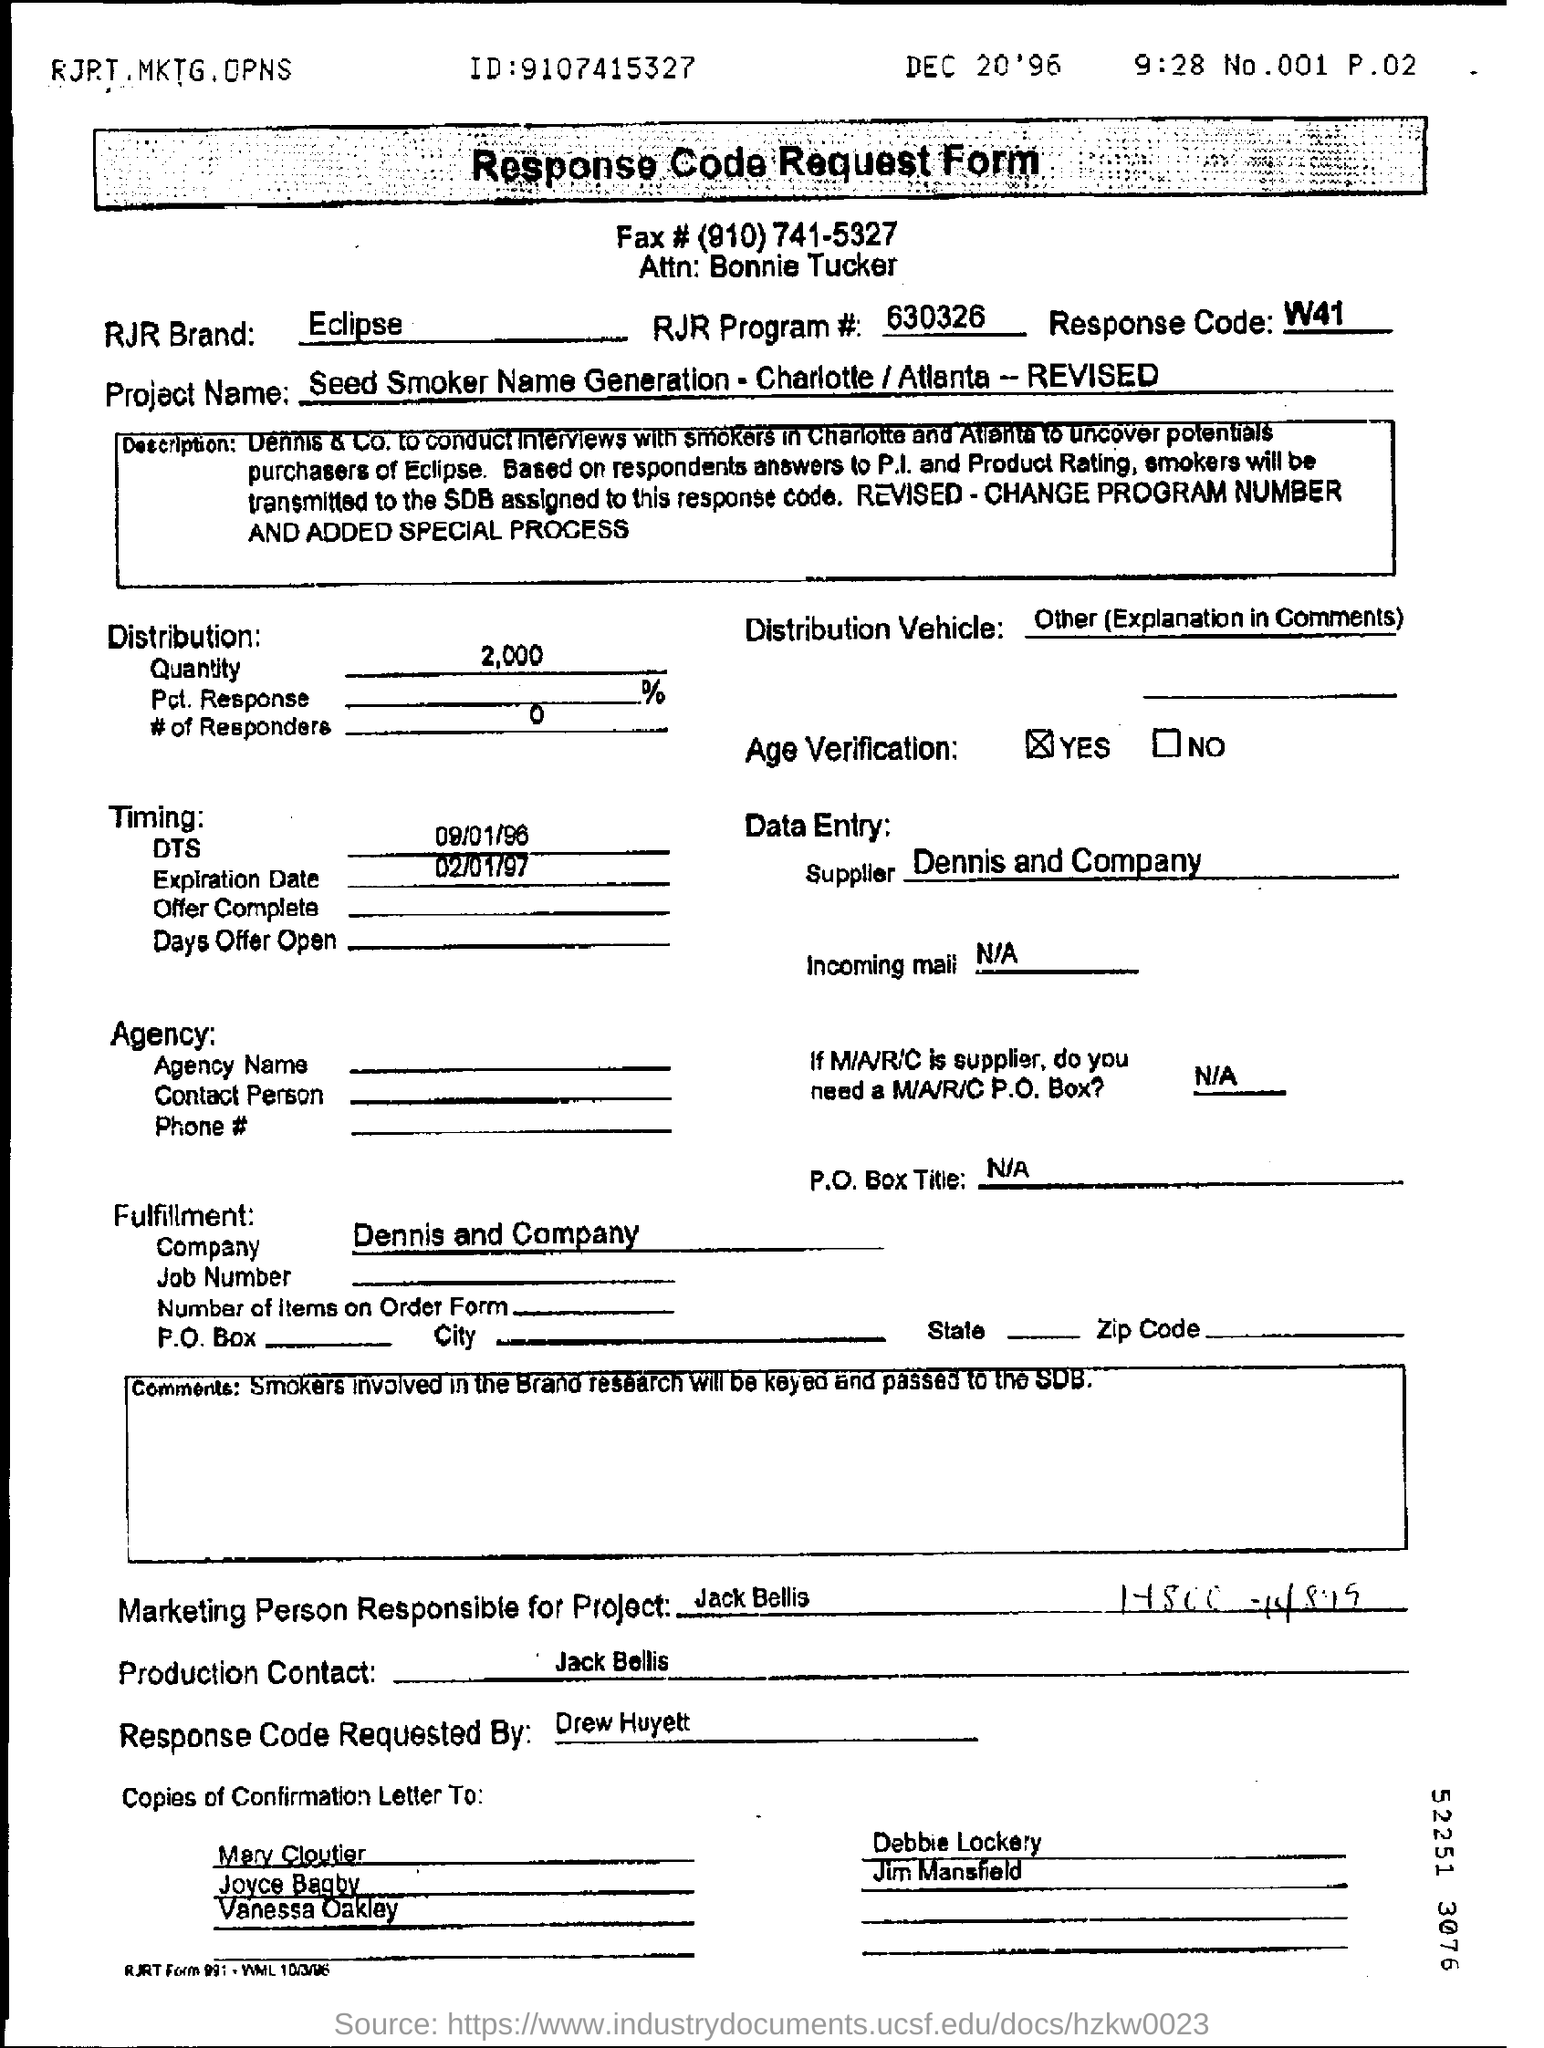Indicate a few pertinent items in this graphic. The marketing person responsible for this is Jack Bellis. Drew Huyett requested the response code. The RJR program number is 630326. The response code is W41. 